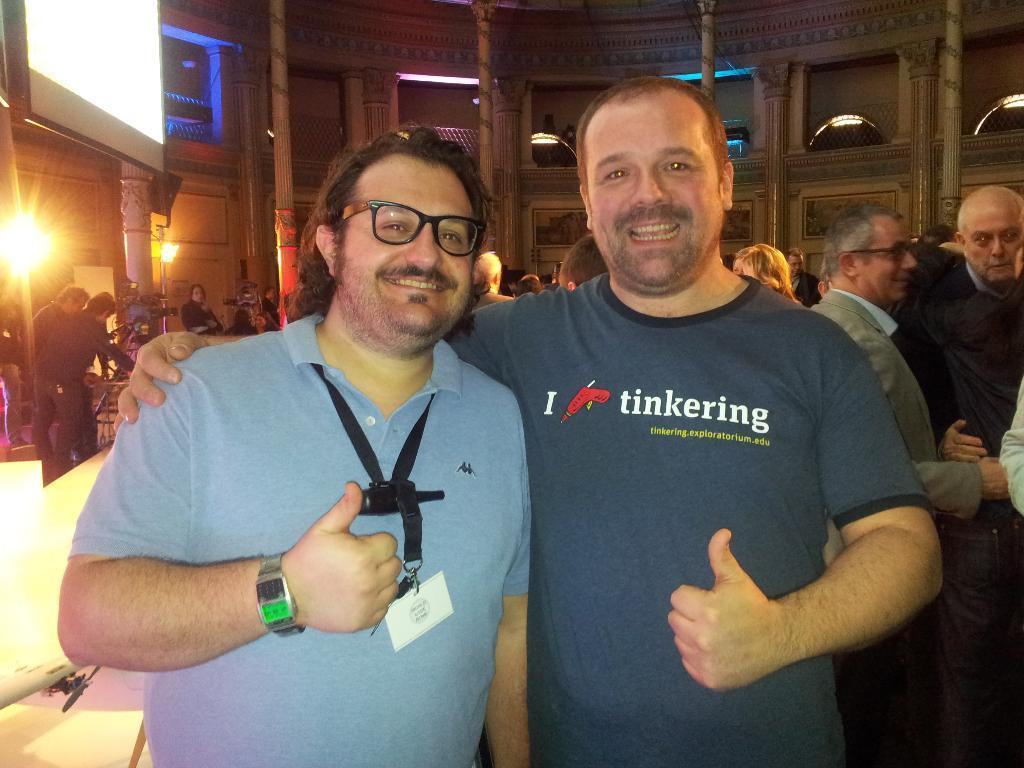Could you give a brief overview of what you see in this image? In this image we can see two persons with a smiling face and behind them, we can see buildings with windows, lights, camera stands and people 